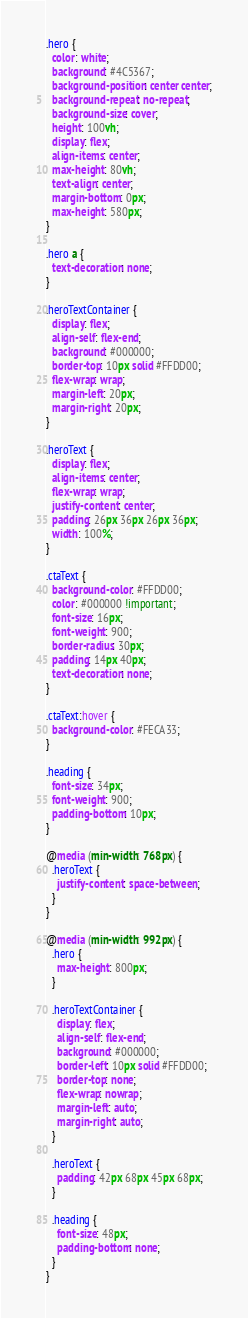Convert code to text. <code><loc_0><loc_0><loc_500><loc_500><_CSS_>.hero {
  color: white;
  background: #4C5367;
  background-position: center center;
  background-repeat: no-repeat;
  background-size: cover;
  height: 100vh;
  display: flex;
  align-items: center;
  max-height: 80vh;
  text-align: center;
  margin-bottom: 0px;
  max-height: 580px;
}

.hero a {
  text-decoration: none;
}

.heroTextContainer {
  display: flex;
  align-self: flex-end;
  background: #000000;
  border-top: 10px solid #FFDD00;
  flex-wrap: wrap;
  margin-left: 20px;
  margin-right: 20px;
}

.heroText {
  display: flex;
  align-items: center;
  flex-wrap: wrap;
  justify-content: center;
  padding: 26px 36px 26px 36px;
  width: 100%;
}

.ctaText {
  background-color: #FFDD00;
  color: #000000 !important;
  font-size: 16px;
  font-weight: 900;
  border-radius: 30px;
  padding: 14px 40px;
  text-decoration: none;
}

.ctaText:hover {
  background-color: #FECA33;
}

.heading {
  font-size: 34px;
  font-weight: 900;
  padding-bottom: 10px;
}

@media (min-width: 768px) {
  .heroText {
    justify-content: space-between;
  }
}

@media (min-width: 992px) {
  .hero {
    max-height: 800px;
  }

  .heroTextContainer {
    display: flex;
    align-self: flex-end;
    background: #000000;
    border-left: 10px solid #FFDD00;
    border-top: none;
    flex-wrap: nowrap;
    margin-left: auto;
    margin-right: auto;
  }

  .heroText {
    padding: 42px 68px 45px 68px;
  }

  .heading {
    font-size: 48px;
    padding-bottom: none;
  }
}
</code> 